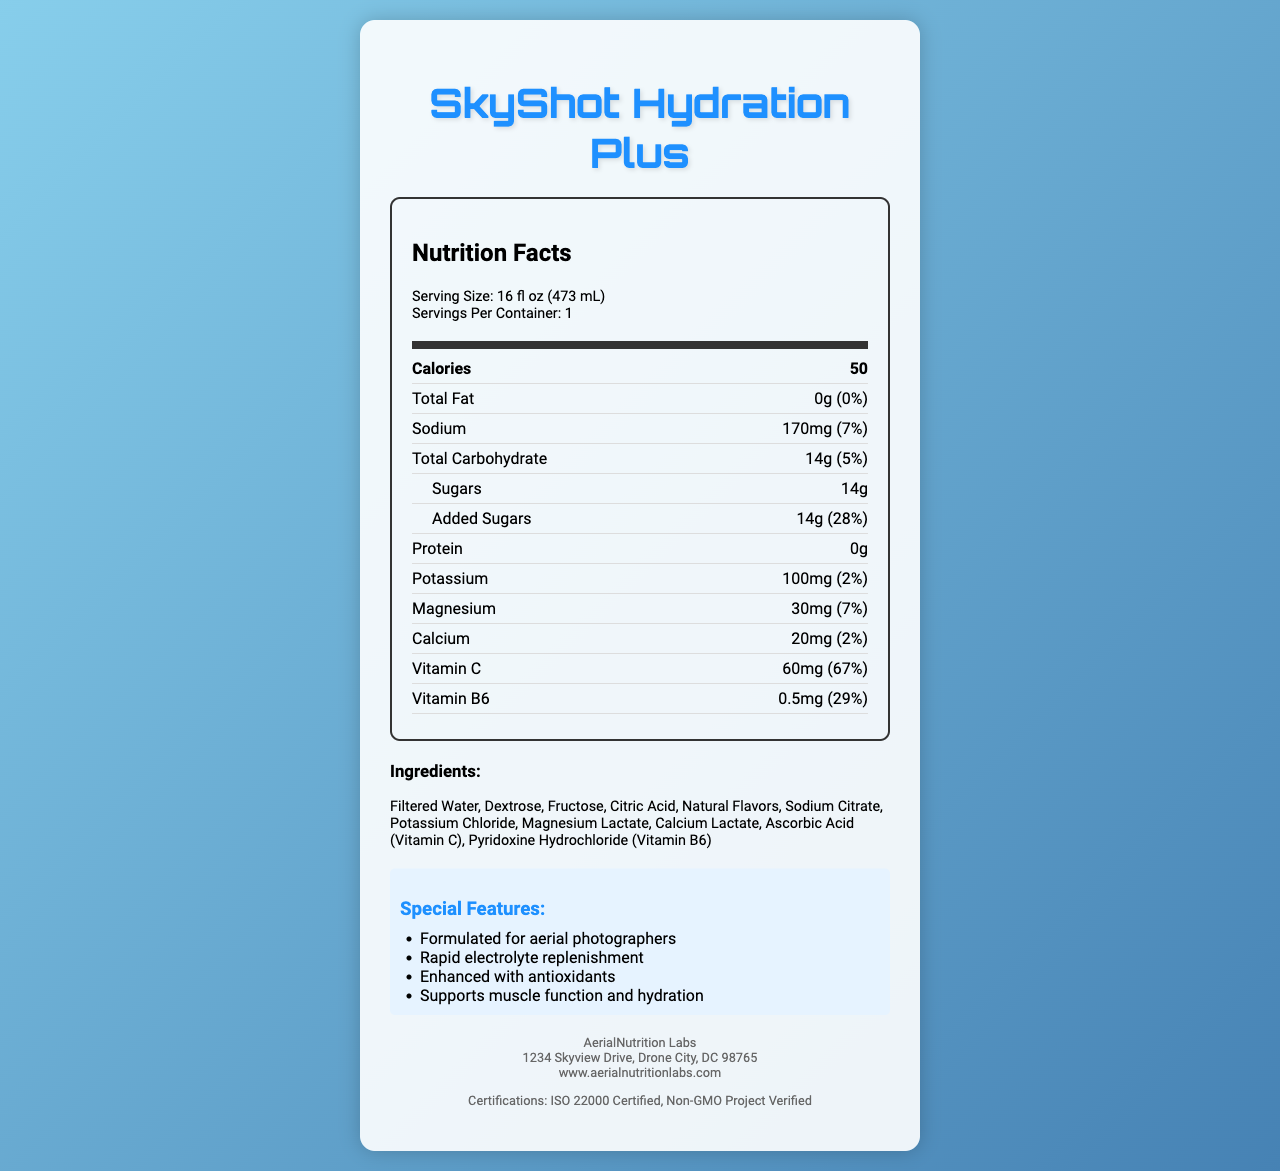what is the serving size? The serving size is explicitly mentioned at the top of the Nutrition Facts label in the serving info section.
Answer: 16 fl oz (473 mL) what is the total carbohydrate amount per serving? The total carbohydrate amount per serving is listed in the nutrient row under Total Carbohydrate.
Answer: 14g how many calories are in one serving? The calorie count per serving is given in the bold nutrient row right after the nutrition header.
Answer: 50 calories how much sodium does this drink contain? The amount of sodium is specified in the nutrient row labeled Sodium.
Answer: 170mg what percentage of the daily value of vitamin C does one serving provide? The percentage of vitamin C is provided in the nutrient row labeled Vitamin C.
Answer: 67% which of the following ingredients is not listed? A. Dextrose B. Fructose C. Aspartame D. Potassium Chloride The ingredients listed do not include Aspartame; Dextrose, Fructose, and Potassium Chloride are listed.
Answer: C. Aspartame what is the vitamin B6 content per serving? A. 0.2mg B. 0.5mg C. 1.0mg D. 2.0mg The vitamin B6 content is listed as 0.5mg per serving.
Answer: B. 0.5mg is the product free from common allergens? The allergen information indicates that the product contains no common allergens.
Answer: Yes describe the special features of SkyShot Hydration Plus. These special features are listed in the special features section of the document.
Answer: Formulated for aerial photographers, rapid electrolyte replenishment, enhanced with antioxidants, supports muscle function and hydration what storage instructions are given for the product? The storage instructions are explicitly mentioned in the document.
Answer: Best served chilled. Refrigerate after opening and consume within 24 hours. who manufactures SkyShot Hydration Plus? The manufacturer info section identifies AerialNutrition Labs as the manufacturer.
Answer: AerialNutrition Labs what certifications does the product have? A. USDA Organic B. ISO 22000 Certified C. Non-GMO Project Verified D. FDA Approved The certifications listed are ISO 22000 Certified and Non-GMO Project Verified.
Answer: B. ISO 22000 Certified, C. Non-GMO Project Verified how many servings are in one container? The servings per container are mentioned in the serving info section.
Answer: 1 what is the amount of added sugars in the product? The added sugars amount is specified in the nutrient row under Added Sugars.
Answer: 14g can you determine the price of SkyShot Hydration Plus from this document? The document does not provide any pricing details.
Answer: Not enough information summarize the main idea of the document. The summary encompasses all sections and key details presented in the document.
Answer: The document provides the nutrition facts, ingredients, special features, storage instructions, manufacturer information, and certifications for SkyShot Hydration Plus, an electrolyte-rich sports drink formulated for aerial photographers working in hot conditions. what is the total fat content per serving? The total fat content is listed as 0g in the nutrient row labeled Total Fat.
Answer: 0g 